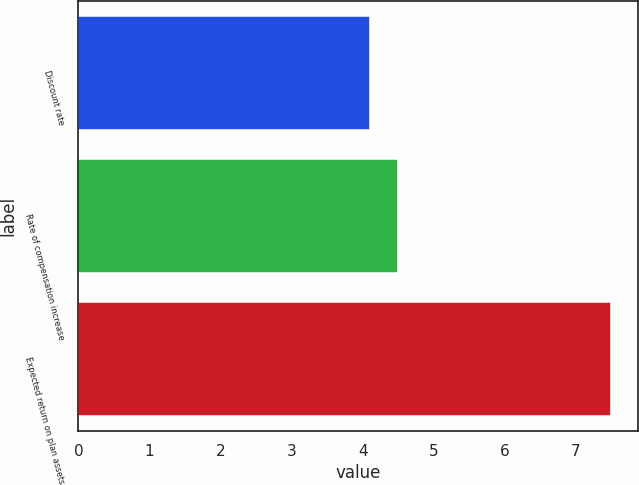<chart> <loc_0><loc_0><loc_500><loc_500><bar_chart><fcel>Discount rate<fcel>Rate of compensation increase<fcel>Expected return on plan assets<nl><fcel>4.1<fcel>4.5<fcel>7.5<nl></chart> 